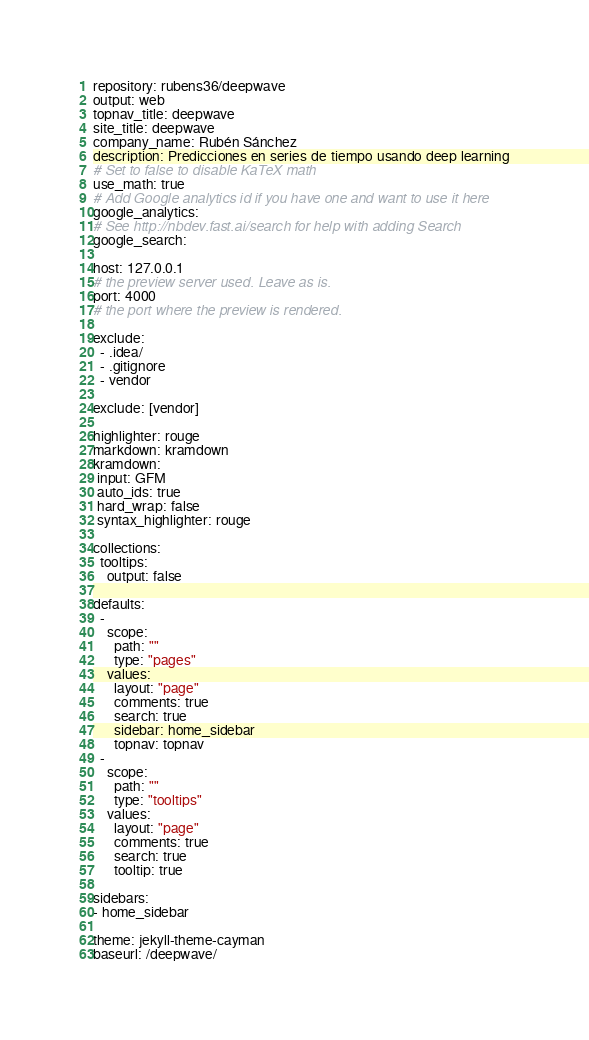Convert code to text. <code><loc_0><loc_0><loc_500><loc_500><_YAML_>repository: rubens36/deepwave
output: web
topnav_title: deepwave
site_title: deepwave
company_name: Rubén Sánchez
description: Predicciones en series de tiempo usando deep learning
# Set to false to disable KaTeX math
use_math: true
# Add Google analytics id if you have one and want to use it here
google_analytics:
# See http://nbdev.fast.ai/search for help with adding Search
google_search:

host: 127.0.0.1
# the preview server used. Leave as is.
port: 4000
# the port where the preview is rendered.

exclude:
  - .idea/
  - .gitignore
  - vendor
 
exclude: [vendor]

highlighter: rouge
markdown: kramdown
kramdown:
 input: GFM
 auto_ids: true
 hard_wrap: false
 syntax_highlighter: rouge

collections:
  tooltips:
    output: false

defaults:
  -
    scope:
      path: ""
      type: "pages"
    values:
      layout: "page"
      comments: true
      search: true
      sidebar: home_sidebar
      topnav: topnav
  -
    scope:
      path: ""
      type: "tooltips"
    values:
      layout: "page"
      comments: true
      search: true
      tooltip: true

sidebars:
- home_sidebar

theme: jekyll-theme-cayman
baseurl: /deepwave/</code> 